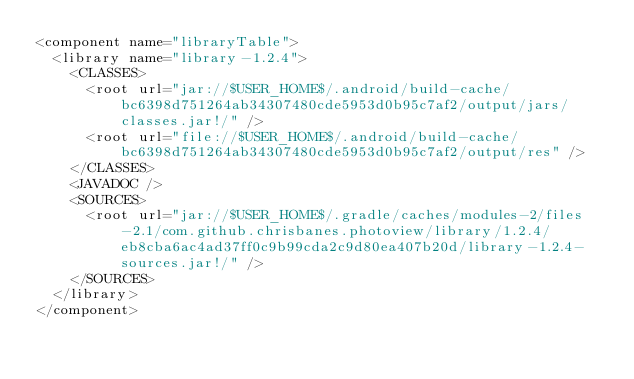<code> <loc_0><loc_0><loc_500><loc_500><_XML_><component name="libraryTable">
  <library name="library-1.2.4">
    <CLASSES>
      <root url="jar://$USER_HOME$/.android/build-cache/bc6398d751264ab34307480cde5953d0b95c7af2/output/jars/classes.jar!/" />
      <root url="file://$USER_HOME$/.android/build-cache/bc6398d751264ab34307480cde5953d0b95c7af2/output/res" />
    </CLASSES>
    <JAVADOC />
    <SOURCES>
      <root url="jar://$USER_HOME$/.gradle/caches/modules-2/files-2.1/com.github.chrisbanes.photoview/library/1.2.4/eb8cba6ac4ad37ff0c9b99cda2c9d80ea407b20d/library-1.2.4-sources.jar!/" />
    </SOURCES>
  </library>
</component></code> 